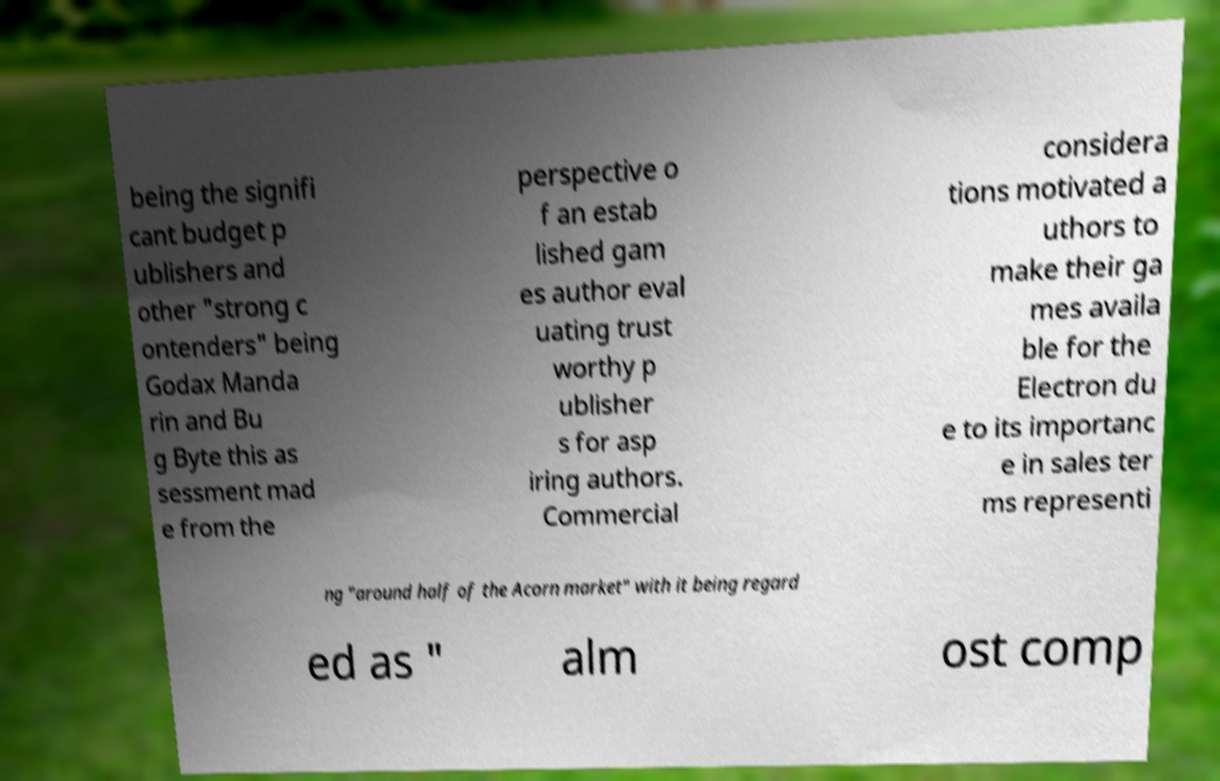There's text embedded in this image that I need extracted. Can you transcribe it verbatim? being the signifi cant budget p ublishers and other "strong c ontenders" being Godax Manda rin and Bu g Byte this as sessment mad e from the perspective o f an estab lished gam es author eval uating trust worthy p ublisher s for asp iring authors. Commercial considera tions motivated a uthors to make their ga mes availa ble for the Electron du e to its importanc e in sales ter ms representi ng "around half of the Acorn market" with it being regard ed as " alm ost comp 